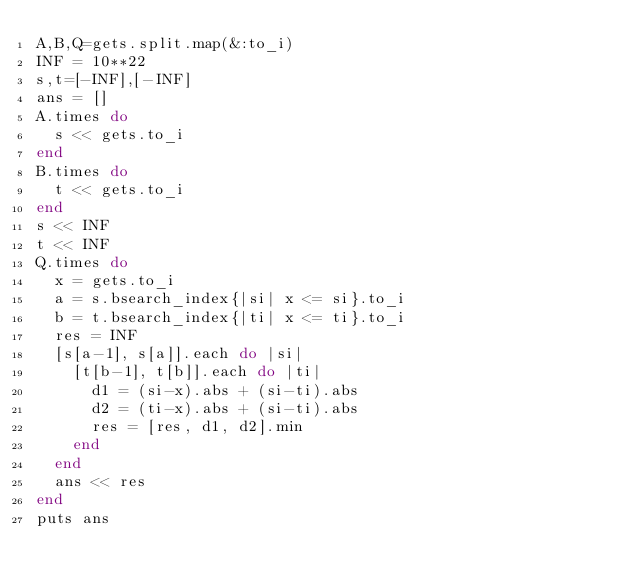<code> <loc_0><loc_0><loc_500><loc_500><_Ruby_>A,B,Q=gets.split.map(&:to_i)
INF = 10**22
s,t=[-INF],[-INF]
ans = []
A.times do
  s << gets.to_i
end
B.times do
  t << gets.to_i
end
s << INF
t << INF
Q.times do
  x = gets.to_i
  a = s.bsearch_index{|si| x <= si}.to_i
  b = t.bsearch_index{|ti| x <= ti}.to_i
  res = INF
  [s[a-1], s[a]].each do |si|
    [t[b-1], t[b]].each do |ti|
      d1 = (si-x).abs + (si-ti).abs
      d2 = (ti-x).abs + (si-ti).abs
      res = [res, d1, d2].min
    end
  end
  ans << res
end
puts ans
</code> 